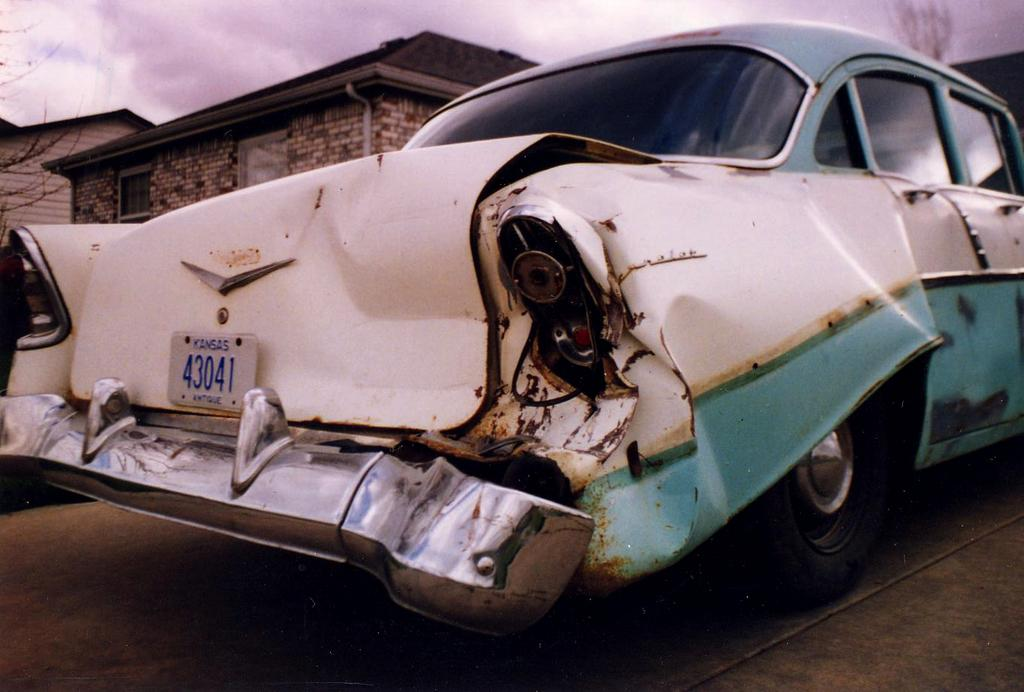What is the main subject of the image? The main subject of the image is a car. Where is the car located in the image? The car is parked on the road in the image. What is the condition of the car? The rear part of the car is damaged. What can be seen behind the car in the image? There are houses behind the car. What is visible at the top of the image? The sky is visible at the top of the image. How much art can be seen on the car in the image? There is no art visible on the car in the image. Can you tell me how many snails are crawling on the car in the image? There are no snails present on the car in the image. 